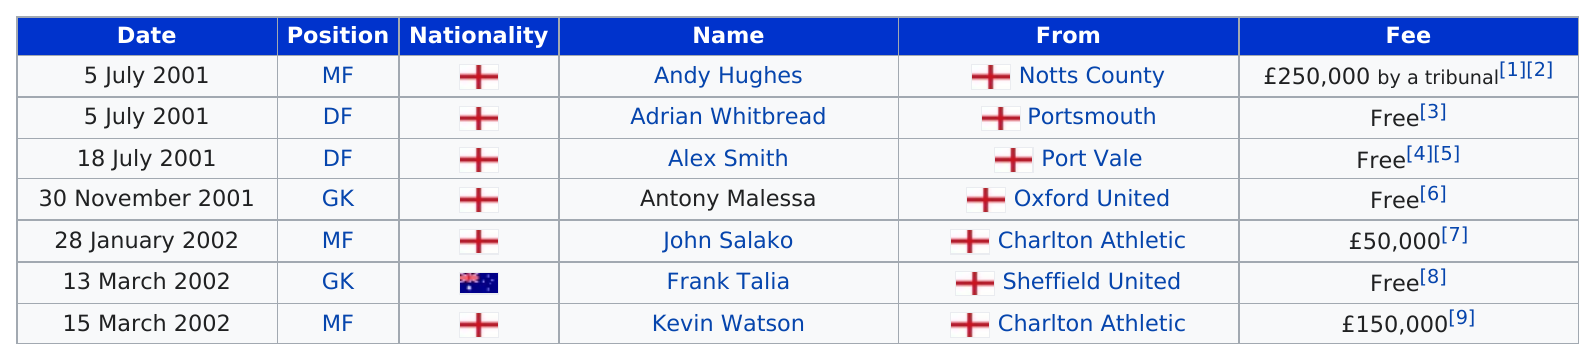List a handful of essential elements in this visual. The total number of free fees is 4. John Salako was transferred in the year 2002. On July 5th, 2001, Andy Huges and Adrian Whitbread both transferred. In 2002, Australia had the least transfers in of all the countries. It has been determined that Andy Hughes is from the soccer club Notts County. 